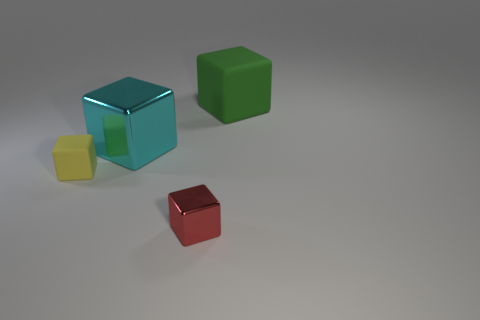What could be the possible uses for objects like those depicted in the image? Objects similar to the cubes in the image might be used in a variety of contexts, such as educational tools for teaching geometry and color recognition to children, placeholders in a three-dimensional modelling software, or as part of a visual composition in a modern art installation. 